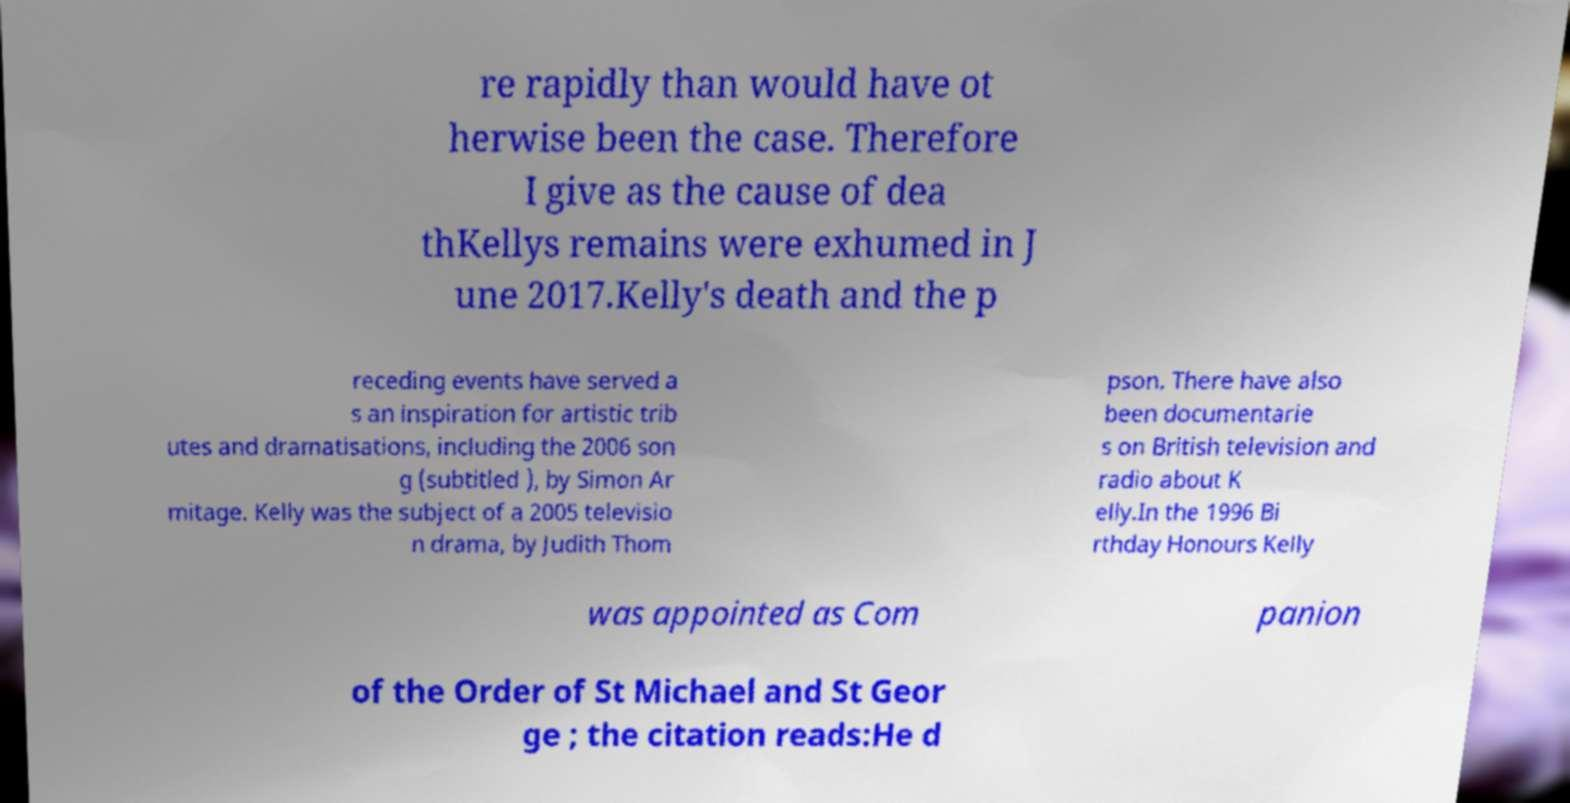I need the written content from this picture converted into text. Can you do that? re rapidly than would have ot herwise been the case. Therefore I give as the cause of dea thKellys remains were exhumed in J une 2017.Kelly's death and the p receding events have served a s an inspiration for artistic trib utes and dramatisations, including the 2006 son g (subtitled ), by Simon Ar mitage. Kelly was the subject of a 2005 televisio n drama, by Judith Thom pson. There have also been documentarie s on British television and radio about K elly.In the 1996 Bi rthday Honours Kelly was appointed as Com panion of the Order of St Michael and St Geor ge ; the citation reads:He d 